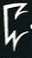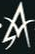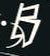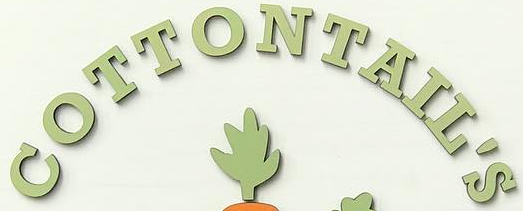What words can you see in these images in sequence, separated by a semicolon? C; A; B; COTTONTAIL'S 